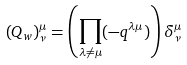<formula> <loc_0><loc_0><loc_500><loc_500>( Q _ { w } ) ^ { \mu } _ { \nu } = \left ( \prod _ { \lambda \not = \mu } ( - q ^ { \lambda \mu } ) \right ) \delta ^ { \mu } _ { \nu }</formula> 